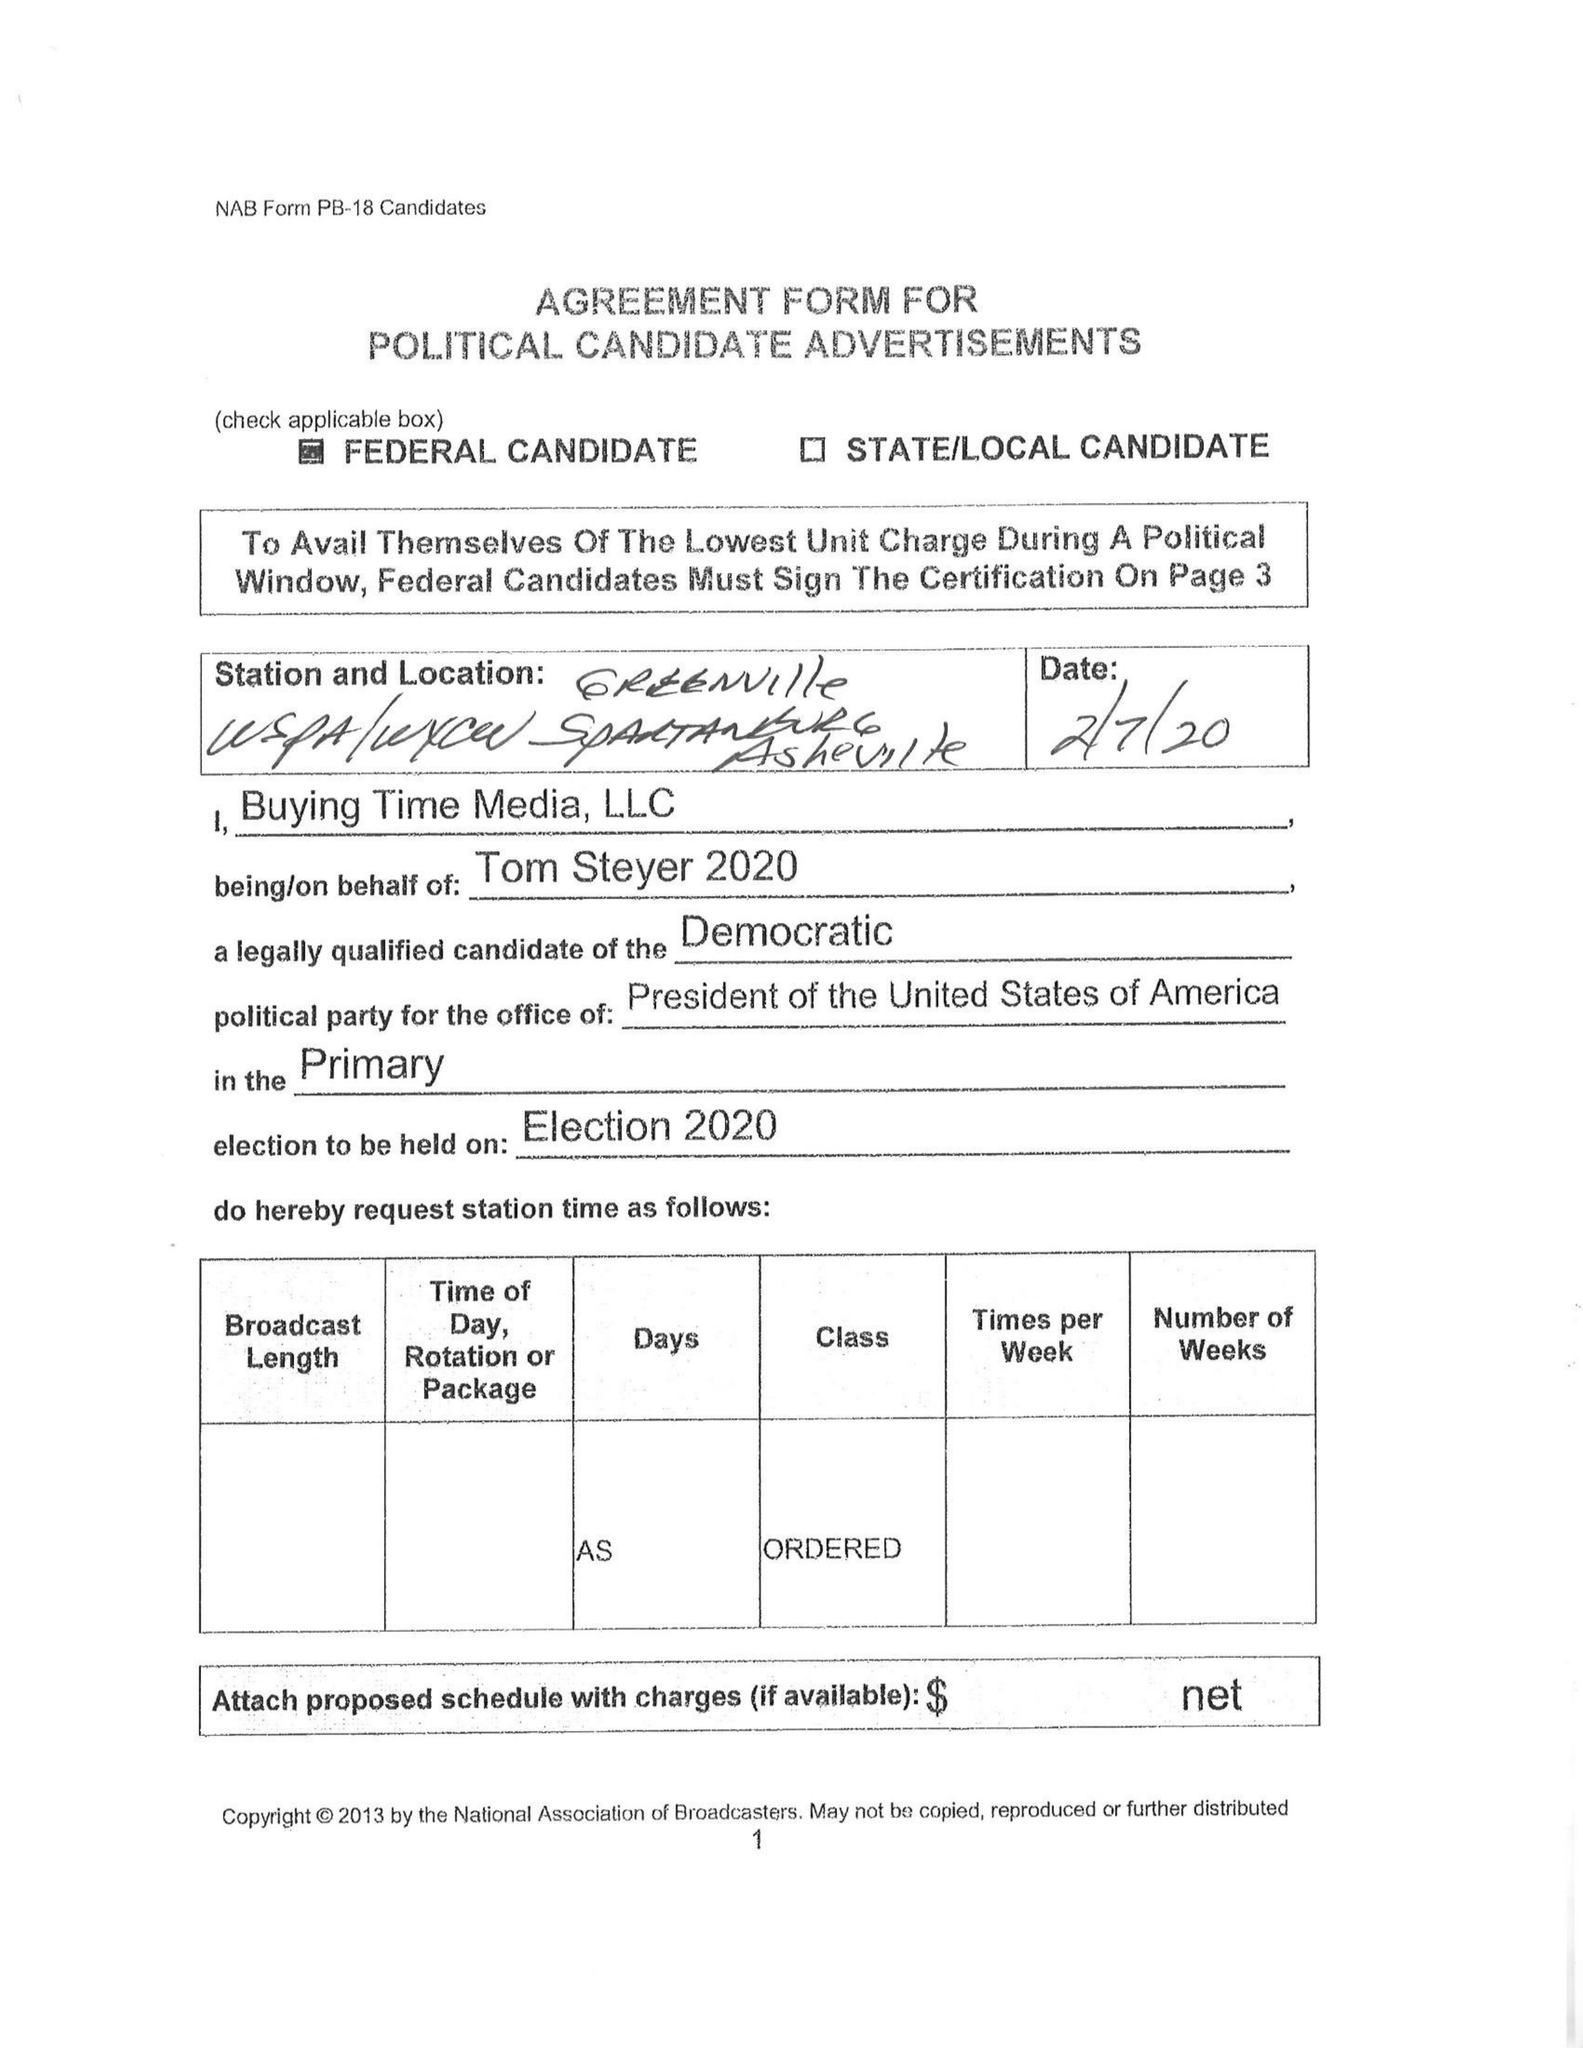What is the value for the advertiser?
Answer the question using a single word or phrase. TOM STEYER 2020 